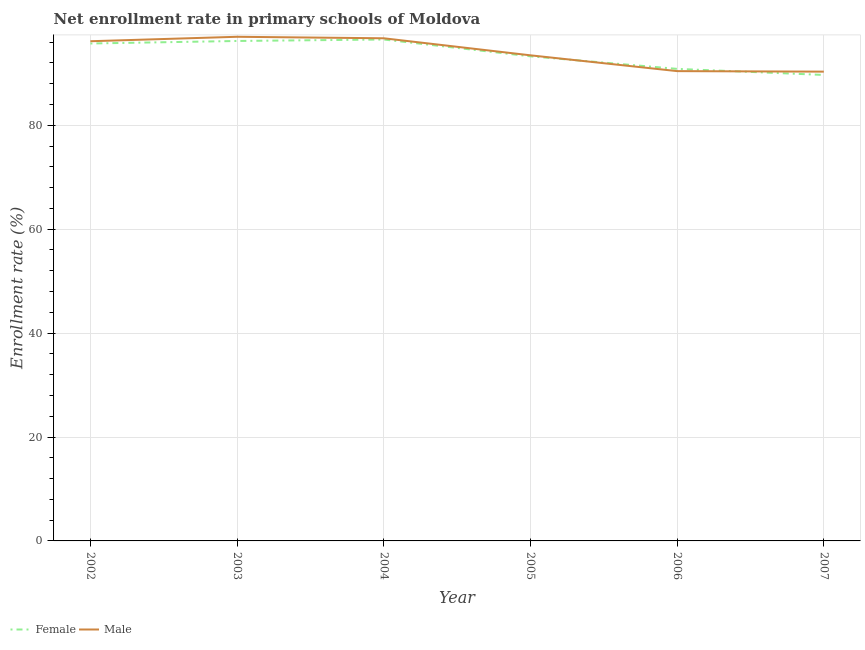What is the enrollment rate of female students in 2003?
Your response must be concise. 96.23. Across all years, what is the maximum enrollment rate of female students?
Give a very brief answer. 96.51. Across all years, what is the minimum enrollment rate of male students?
Offer a very short reply. 90.32. What is the total enrollment rate of female students in the graph?
Provide a succinct answer. 562.29. What is the difference between the enrollment rate of female students in 2003 and that in 2004?
Offer a terse response. -0.28. What is the difference between the enrollment rate of female students in 2004 and the enrollment rate of male students in 2003?
Offer a very short reply. -0.53. What is the average enrollment rate of female students per year?
Provide a short and direct response. 93.71. In the year 2006, what is the difference between the enrollment rate of male students and enrollment rate of female students?
Ensure brevity in your answer.  -0.43. What is the ratio of the enrollment rate of female students in 2005 to that in 2007?
Your answer should be compact. 1.04. What is the difference between the highest and the second highest enrollment rate of female students?
Your answer should be very brief. 0.28. What is the difference between the highest and the lowest enrollment rate of male students?
Give a very brief answer. 6.71. In how many years, is the enrollment rate of female students greater than the average enrollment rate of female students taken over all years?
Your answer should be very brief. 3. Is the sum of the enrollment rate of female students in 2002 and 2007 greater than the maximum enrollment rate of male students across all years?
Offer a very short reply. Yes. How many years are there in the graph?
Provide a succinct answer. 6. Are the values on the major ticks of Y-axis written in scientific E-notation?
Provide a short and direct response. No. Does the graph contain any zero values?
Provide a short and direct response. No. How are the legend labels stacked?
Keep it short and to the point. Horizontal. What is the title of the graph?
Ensure brevity in your answer.  Net enrollment rate in primary schools of Moldova. What is the label or title of the Y-axis?
Your response must be concise. Enrollment rate (%). What is the Enrollment rate (%) of Female in 2002?
Your response must be concise. 95.74. What is the Enrollment rate (%) in Male in 2002?
Provide a succinct answer. 96.18. What is the Enrollment rate (%) of Female in 2003?
Your answer should be very brief. 96.23. What is the Enrollment rate (%) of Male in 2003?
Give a very brief answer. 97.03. What is the Enrollment rate (%) in Female in 2004?
Offer a very short reply. 96.51. What is the Enrollment rate (%) of Male in 2004?
Your response must be concise. 96.74. What is the Enrollment rate (%) of Female in 2005?
Offer a very short reply. 93.27. What is the Enrollment rate (%) in Male in 2005?
Your response must be concise. 93.47. What is the Enrollment rate (%) in Female in 2006?
Your answer should be compact. 90.86. What is the Enrollment rate (%) in Male in 2006?
Provide a succinct answer. 90.42. What is the Enrollment rate (%) of Female in 2007?
Make the answer very short. 89.69. What is the Enrollment rate (%) in Male in 2007?
Offer a terse response. 90.32. Across all years, what is the maximum Enrollment rate (%) in Female?
Offer a very short reply. 96.51. Across all years, what is the maximum Enrollment rate (%) of Male?
Offer a very short reply. 97.03. Across all years, what is the minimum Enrollment rate (%) in Female?
Offer a very short reply. 89.69. Across all years, what is the minimum Enrollment rate (%) in Male?
Offer a very short reply. 90.32. What is the total Enrollment rate (%) in Female in the graph?
Your answer should be compact. 562.29. What is the total Enrollment rate (%) of Male in the graph?
Give a very brief answer. 564.17. What is the difference between the Enrollment rate (%) in Female in 2002 and that in 2003?
Offer a terse response. -0.48. What is the difference between the Enrollment rate (%) in Male in 2002 and that in 2003?
Provide a short and direct response. -0.86. What is the difference between the Enrollment rate (%) of Female in 2002 and that in 2004?
Keep it short and to the point. -0.77. What is the difference between the Enrollment rate (%) in Male in 2002 and that in 2004?
Give a very brief answer. -0.57. What is the difference between the Enrollment rate (%) of Female in 2002 and that in 2005?
Offer a terse response. 2.47. What is the difference between the Enrollment rate (%) of Male in 2002 and that in 2005?
Make the answer very short. 2.71. What is the difference between the Enrollment rate (%) in Female in 2002 and that in 2006?
Offer a very short reply. 4.89. What is the difference between the Enrollment rate (%) in Male in 2002 and that in 2006?
Keep it short and to the point. 5.75. What is the difference between the Enrollment rate (%) in Female in 2002 and that in 2007?
Offer a terse response. 6.06. What is the difference between the Enrollment rate (%) in Male in 2002 and that in 2007?
Provide a short and direct response. 5.85. What is the difference between the Enrollment rate (%) of Female in 2003 and that in 2004?
Keep it short and to the point. -0.28. What is the difference between the Enrollment rate (%) of Male in 2003 and that in 2004?
Your answer should be very brief. 0.29. What is the difference between the Enrollment rate (%) of Female in 2003 and that in 2005?
Offer a terse response. 2.95. What is the difference between the Enrollment rate (%) of Male in 2003 and that in 2005?
Provide a short and direct response. 3.57. What is the difference between the Enrollment rate (%) of Female in 2003 and that in 2006?
Offer a very short reply. 5.37. What is the difference between the Enrollment rate (%) of Male in 2003 and that in 2006?
Offer a very short reply. 6.61. What is the difference between the Enrollment rate (%) of Female in 2003 and that in 2007?
Give a very brief answer. 6.54. What is the difference between the Enrollment rate (%) in Male in 2003 and that in 2007?
Keep it short and to the point. 6.71. What is the difference between the Enrollment rate (%) of Female in 2004 and that in 2005?
Your answer should be compact. 3.23. What is the difference between the Enrollment rate (%) of Male in 2004 and that in 2005?
Offer a very short reply. 3.28. What is the difference between the Enrollment rate (%) of Female in 2004 and that in 2006?
Offer a very short reply. 5.65. What is the difference between the Enrollment rate (%) in Male in 2004 and that in 2006?
Your answer should be compact. 6.32. What is the difference between the Enrollment rate (%) in Female in 2004 and that in 2007?
Offer a very short reply. 6.82. What is the difference between the Enrollment rate (%) of Male in 2004 and that in 2007?
Ensure brevity in your answer.  6.42. What is the difference between the Enrollment rate (%) of Female in 2005 and that in 2006?
Provide a succinct answer. 2.42. What is the difference between the Enrollment rate (%) of Male in 2005 and that in 2006?
Give a very brief answer. 3.04. What is the difference between the Enrollment rate (%) of Female in 2005 and that in 2007?
Offer a terse response. 3.59. What is the difference between the Enrollment rate (%) in Male in 2005 and that in 2007?
Make the answer very short. 3.14. What is the difference between the Enrollment rate (%) of Female in 2006 and that in 2007?
Your answer should be compact. 1.17. What is the difference between the Enrollment rate (%) of Male in 2006 and that in 2007?
Offer a terse response. 0.1. What is the difference between the Enrollment rate (%) in Female in 2002 and the Enrollment rate (%) in Male in 2003?
Make the answer very short. -1.29. What is the difference between the Enrollment rate (%) of Female in 2002 and the Enrollment rate (%) of Male in 2004?
Ensure brevity in your answer.  -1. What is the difference between the Enrollment rate (%) in Female in 2002 and the Enrollment rate (%) in Male in 2005?
Make the answer very short. 2.28. What is the difference between the Enrollment rate (%) in Female in 2002 and the Enrollment rate (%) in Male in 2006?
Offer a terse response. 5.32. What is the difference between the Enrollment rate (%) of Female in 2002 and the Enrollment rate (%) of Male in 2007?
Your response must be concise. 5.42. What is the difference between the Enrollment rate (%) of Female in 2003 and the Enrollment rate (%) of Male in 2004?
Offer a terse response. -0.52. What is the difference between the Enrollment rate (%) of Female in 2003 and the Enrollment rate (%) of Male in 2005?
Provide a short and direct response. 2.76. What is the difference between the Enrollment rate (%) of Female in 2003 and the Enrollment rate (%) of Male in 2006?
Make the answer very short. 5.8. What is the difference between the Enrollment rate (%) of Female in 2003 and the Enrollment rate (%) of Male in 2007?
Give a very brief answer. 5.9. What is the difference between the Enrollment rate (%) in Female in 2004 and the Enrollment rate (%) in Male in 2005?
Keep it short and to the point. 3.04. What is the difference between the Enrollment rate (%) of Female in 2004 and the Enrollment rate (%) of Male in 2006?
Ensure brevity in your answer.  6.08. What is the difference between the Enrollment rate (%) in Female in 2004 and the Enrollment rate (%) in Male in 2007?
Provide a succinct answer. 6.18. What is the difference between the Enrollment rate (%) in Female in 2005 and the Enrollment rate (%) in Male in 2006?
Keep it short and to the point. 2.85. What is the difference between the Enrollment rate (%) in Female in 2005 and the Enrollment rate (%) in Male in 2007?
Your answer should be compact. 2.95. What is the difference between the Enrollment rate (%) of Female in 2006 and the Enrollment rate (%) of Male in 2007?
Keep it short and to the point. 0.53. What is the average Enrollment rate (%) of Female per year?
Make the answer very short. 93.71. What is the average Enrollment rate (%) of Male per year?
Your answer should be compact. 94.03. In the year 2002, what is the difference between the Enrollment rate (%) in Female and Enrollment rate (%) in Male?
Make the answer very short. -0.44. In the year 2003, what is the difference between the Enrollment rate (%) in Female and Enrollment rate (%) in Male?
Your response must be concise. -0.81. In the year 2004, what is the difference between the Enrollment rate (%) of Female and Enrollment rate (%) of Male?
Make the answer very short. -0.24. In the year 2005, what is the difference between the Enrollment rate (%) of Female and Enrollment rate (%) of Male?
Provide a succinct answer. -0.19. In the year 2006, what is the difference between the Enrollment rate (%) in Female and Enrollment rate (%) in Male?
Provide a short and direct response. 0.43. In the year 2007, what is the difference between the Enrollment rate (%) in Female and Enrollment rate (%) in Male?
Provide a succinct answer. -0.64. What is the ratio of the Enrollment rate (%) in Female in 2002 to that in 2003?
Offer a terse response. 0.99. What is the ratio of the Enrollment rate (%) in Female in 2002 to that in 2004?
Provide a succinct answer. 0.99. What is the ratio of the Enrollment rate (%) of Female in 2002 to that in 2005?
Give a very brief answer. 1.03. What is the ratio of the Enrollment rate (%) in Male in 2002 to that in 2005?
Your response must be concise. 1.03. What is the ratio of the Enrollment rate (%) of Female in 2002 to that in 2006?
Provide a short and direct response. 1.05. What is the ratio of the Enrollment rate (%) of Male in 2002 to that in 2006?
Your answer should be compact. 1.06. What is the ratio of the Enrollment rate (%) of Female in 2002 to that in 2007?
Give a very brief answer. 1.07. What is the ratio of the Enrollment rate (%) of Male in 2002 to that in 2007?
Your answer should be very brief. 1.06. What is the ratio of the Enrollment rate (%) in Female in 2003 to that in 2004?
Your answer should be compact. 1. What is the ratio of the Enrollment rate (%) of Male in 2003 to that in 2004?
Your answer should be very brief. 1. What is the ratio of the Enrollment rate (%) of Female in 2003 to that in 2005?
Your answer should be very brief. 1.03. What is the ratio of the Enrollment rate (%) in Male in 2003 to that in 2005?
Keep it short and to the point. 1.04. What is the ratio of the Enrollment rate (%) in Female in 2003 to that in 2006?
Make the answer very short. 1.06. What is the ratio of the Enrollment rate (%) in Male in 2003 to that in 2006?
Keep it short and to the point. 1.07. What is the ratio of the Enrollment rate (%) in Female in 2003 to that in 2007?
Provide a succinct answer. 1.07. What is the ratio of the Enrollment rate (%) in Male in 2003 to that in 2007?
Your answer should be very brief. 1.07. What is the ratio of the Enrollment rate (%) of Female in 2004 to that in 2005?
Make the answer very short. 1.03. What is the ratio of the Enrollment rate (%) in Male in 2004 to that in 2005?
Your response must be concise. 1.04. What is the ratio of the Enrollment rate (%) of Female in 2004 to that in 2006?
Offer a terse response. 1.06. What is the ratio of the Enrollment rate (%) in Male in 2004 to that in 2006?
Offer a terse response. 1.07. What is the ratio of the Enrollment rate (%) in Female in 2004 to that in 2007?
Make the answer very short. 1.08. What is the ratio of the Enrollment rate (%) of Male in 2004 to that in 2007?
Your response must be concise. 1.07. What is the ratio of the Enrollment rate (%) in Female in 2005 to that in 2006?
Give a very brief answer. 1.03. What is the ratio of the Enrollment rate (%) of Male in 2005 to that in 2006?
Ensure brevity in your answer.  1.03. What is the ratio of the Enrollment rate (%) of Male in 2005 to that in 2007?
Keep it short and to the point. 1.03. What is the ratio of the Enrollment rate (%) of Female in 2006 to that in 2007?
Provide a succinct answer. 1.01. What is the ratio of the Enrollment rate (%) of Male in 2006 to that in 2007?
Give a very brief answer. 1. What is the difference between the highest and the second highest Enrollment rate (%) of Female?
Your response must be concise. 0.28. What is the difference between the highest and the second highest Enrollment rate (%) in Male?
Make the answer very short. 0.29. What is the difference between the highest and the lowest Enrollment rate (%) of Female?
Your response must be concise. 6.82. What is the difference between the highest and the lowest Enrollment rate (%) of Male?
Give a very brief answer. 6.71. 